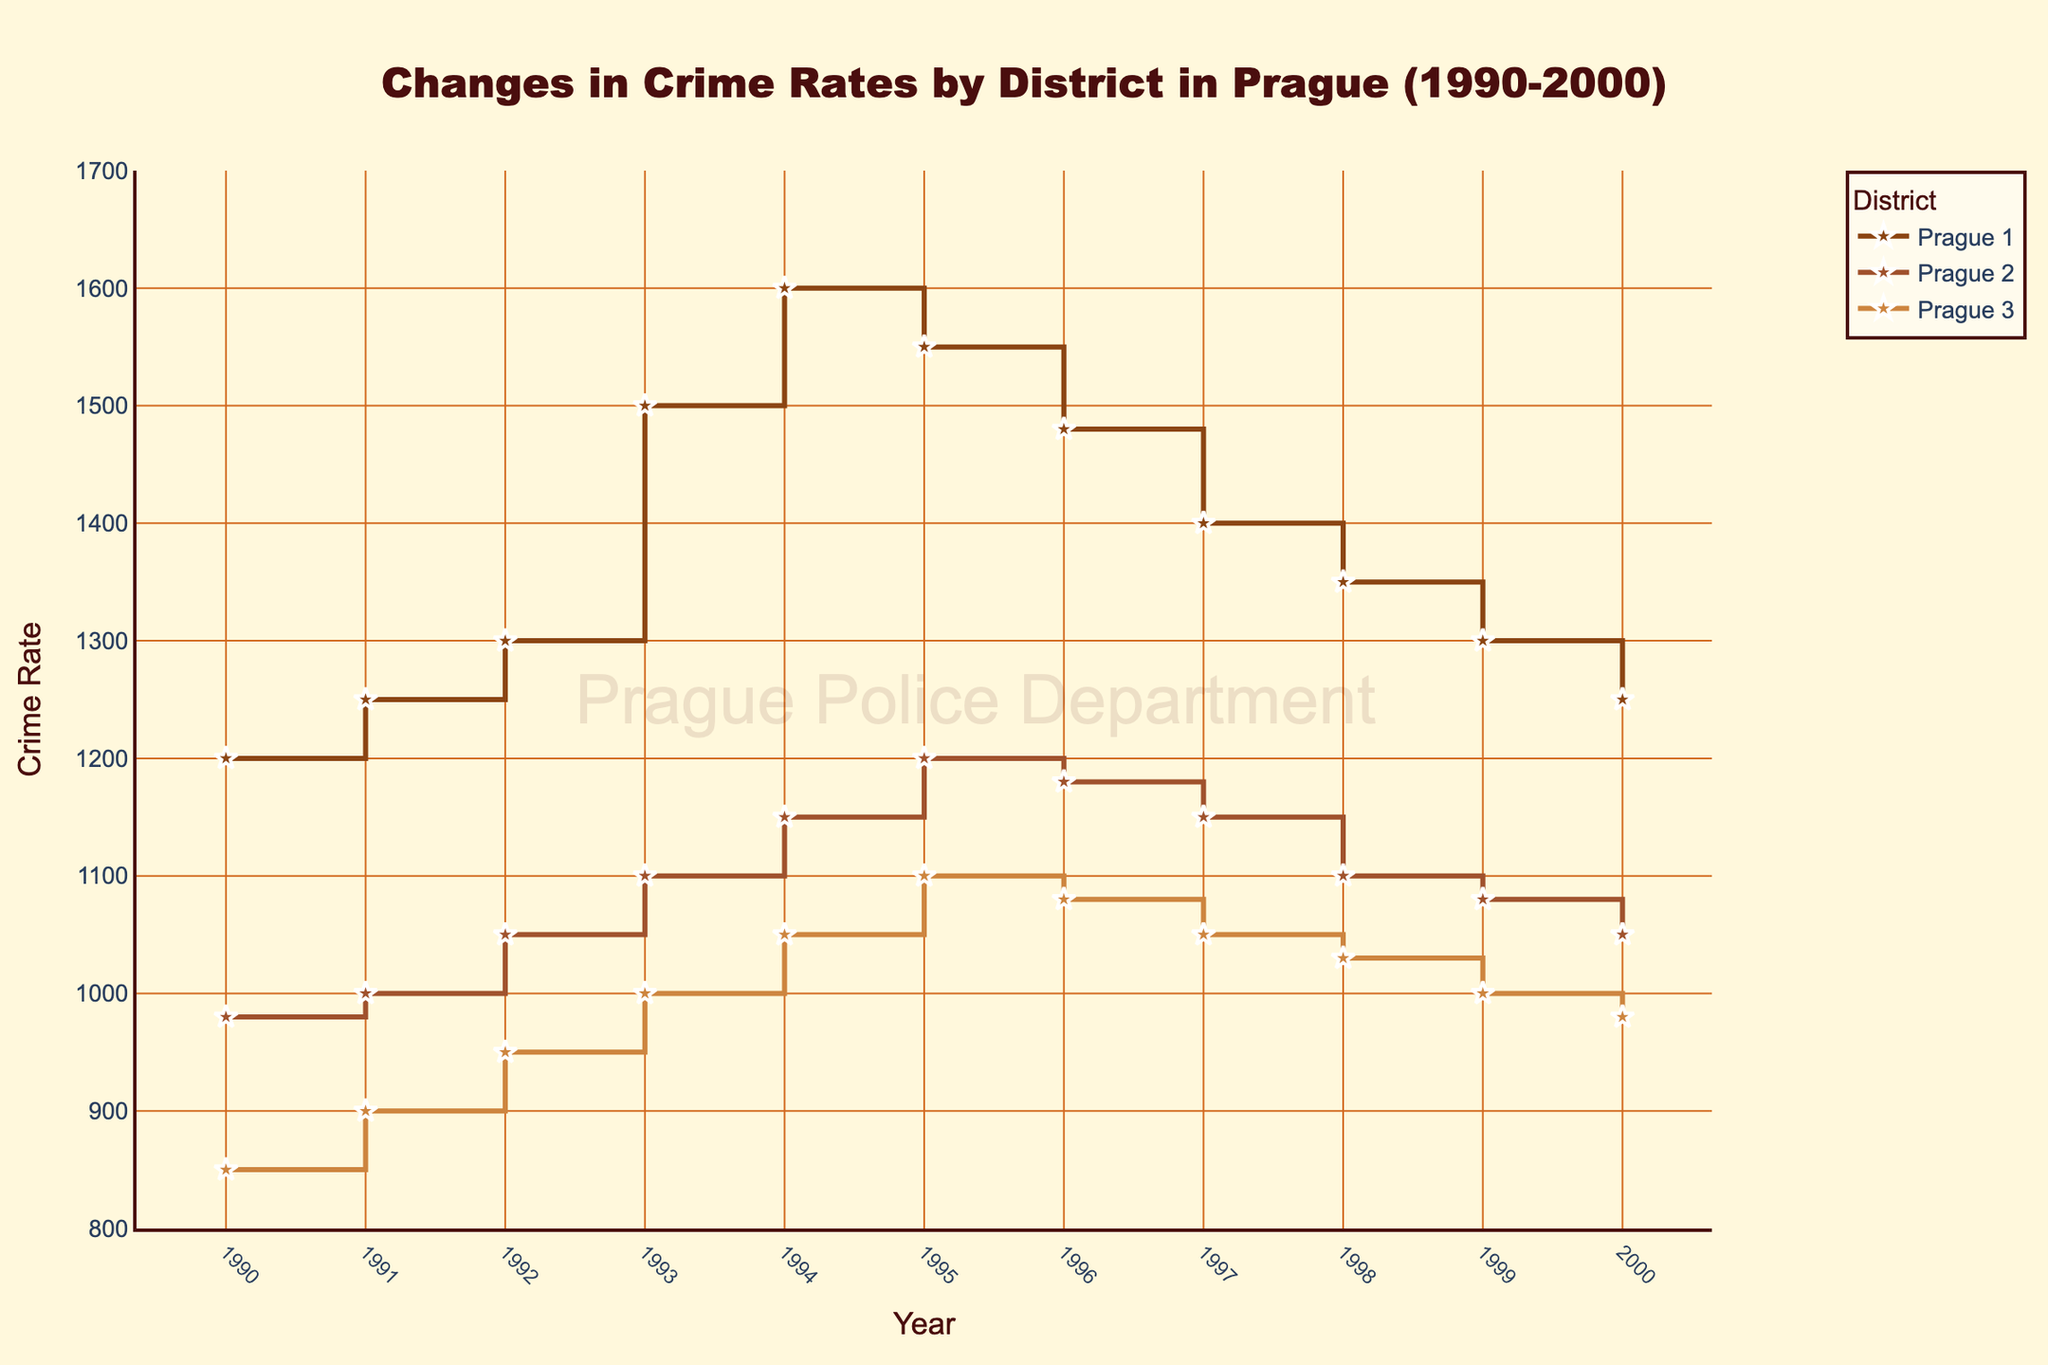what is the title of the plot? The title is the text prominently displayed at the top of the figure. It is used to describe the main subject or focus of the figure.
Answer: Changes in Crime Rates by District in Prague (1990-2000) What is the color of the background? The background color is the color that fills the entire plot area. In this figure, it is described as being a specific type of color.
Answer: Light beige Which year had the highest crime rate in Prague 1? To find the year with the highest crime rate in Prague 1, look at the stair plot for Prague 1 and identify the tallest point on the y-axis.
Answer: 1994 On average, how did the crime rate in Prague 2 change over the decade? Calculate the difference in crime rates between 1990 and 2000, then divide by the number of years (11) to find the average annual change. = (1050 - 980) / 11 ≈ 6.36
Answer: Increased by approximately 6.36 per year Which district had the highest crime rate in 1995? Compare the crime rates for all three districts in the year 1995, and identify the district with the highest value.
Answer: Prague 1 By how much did the crime rate in Prague 3 decrease from 1997 to 2000? Look at the crime rates for Prague 3 in 1997 and 2000. Subtract the latter from the former to find the decrease: 1050 - 980 = 70
Answer: 70 Which district shows a constant decrease in crime rate from 1996 to 2000? Analyze the stair plot for all districts from the year 1996 to 2000. Identify if any district shows a consistent declining trend in the crime rate without any increase.
Answer: Prague 1 In which year did Prague 2 have the same crime rate as Prague 3? Examine the plots for Prague 2 and Prague 3 year by year to identify the year where their crime rates are the same.
Answer: Never What is the range of crime rates in Prague 3 throughout the decade? Identify the minimum and maximum crime rates for Prague 3 between 1990 and 2000, then subtract the minimum from the maximum to find the range: 1100 - 850 = 250
Answer: 250 During which consecutive years did Prague 1 see the largest spike in crime rate? Observe the stair plot for Prague 1 and find the interval between two consecutive years where the difference in crime rate is the largest.
Answer: 1992 to 1993 